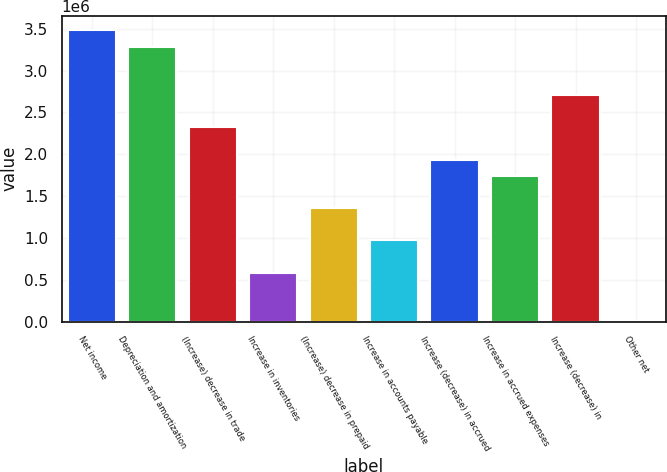Convert chart to OTSL. <chart><loc_0><loc_0><loc_500><loc_500><bar_chart><fcel>Net income<fcel>Depreciation and amortization<fcel>(Increase) decrease in trade<fcel>Increase in inventories<fcel>(Increase) decrease in prepaid<fcel>Increase in accounts payable<fcel>Increase (decrease) in accrued<fcel>Increase in accrued expenses<fcel>Increase (decrease) in<fcel>Other net<nl><fcel>3.48002e+06<fcel>3.28689e+06<fcel>2.32124e+06<fcel>583065<fcel>1.35559e+06<fcel>969326<fcel>1.93498e+06<fcel>1.74185e+06<fcel>2.7075e+06<fcel>3673<nl></chart> 